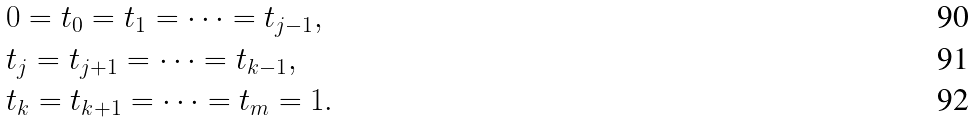<formula> <loc_0><loc_0><loc_500><loc_500>& 0 = t _ { 0 } = t _ { 1 } = \cdots = t _ { j - 1 } , \\ & t _ { j } = t _ { j + 1 } = \cdots = t _ { k - 1 } , \\ & t _ { k } = t _ { k + 1 } = \cdots = t _ { m } = 1 .</formula> 